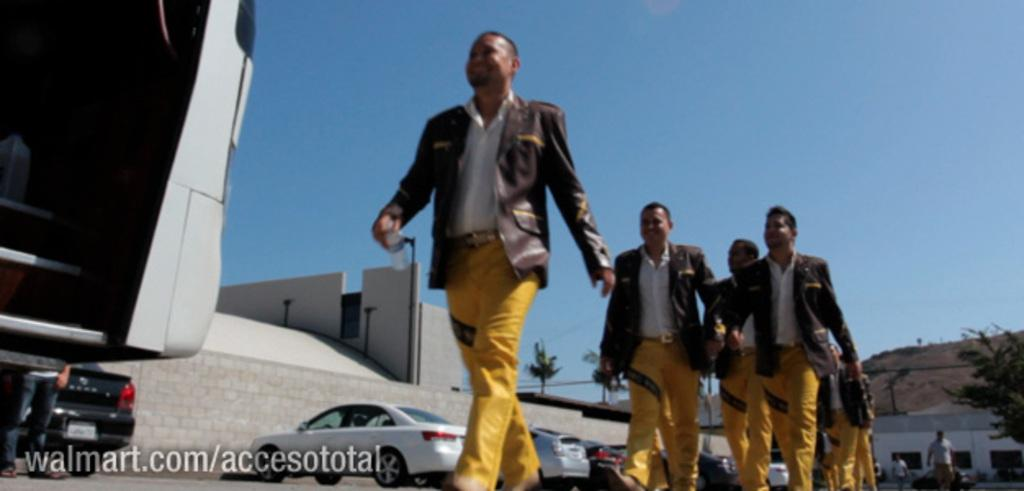What are the people in the image doing? The people in the image are standing on the road. What else can be seen on the road in the image? There are cars parked on the road. What type of vegetation is visible in the image? There are trees visible in the image. What is visible in the background of the image? There are buildings in the background. How would you describe the weather based on the image? The sky is clear in the image, suggesting good weather. How does the guide help the people in the image? There is no guide present in the image; the people are simply standing on the road. What type of smashing can be seen happening in the image? There is no smashing present in the image; it features people standing on the road and parked cars. 